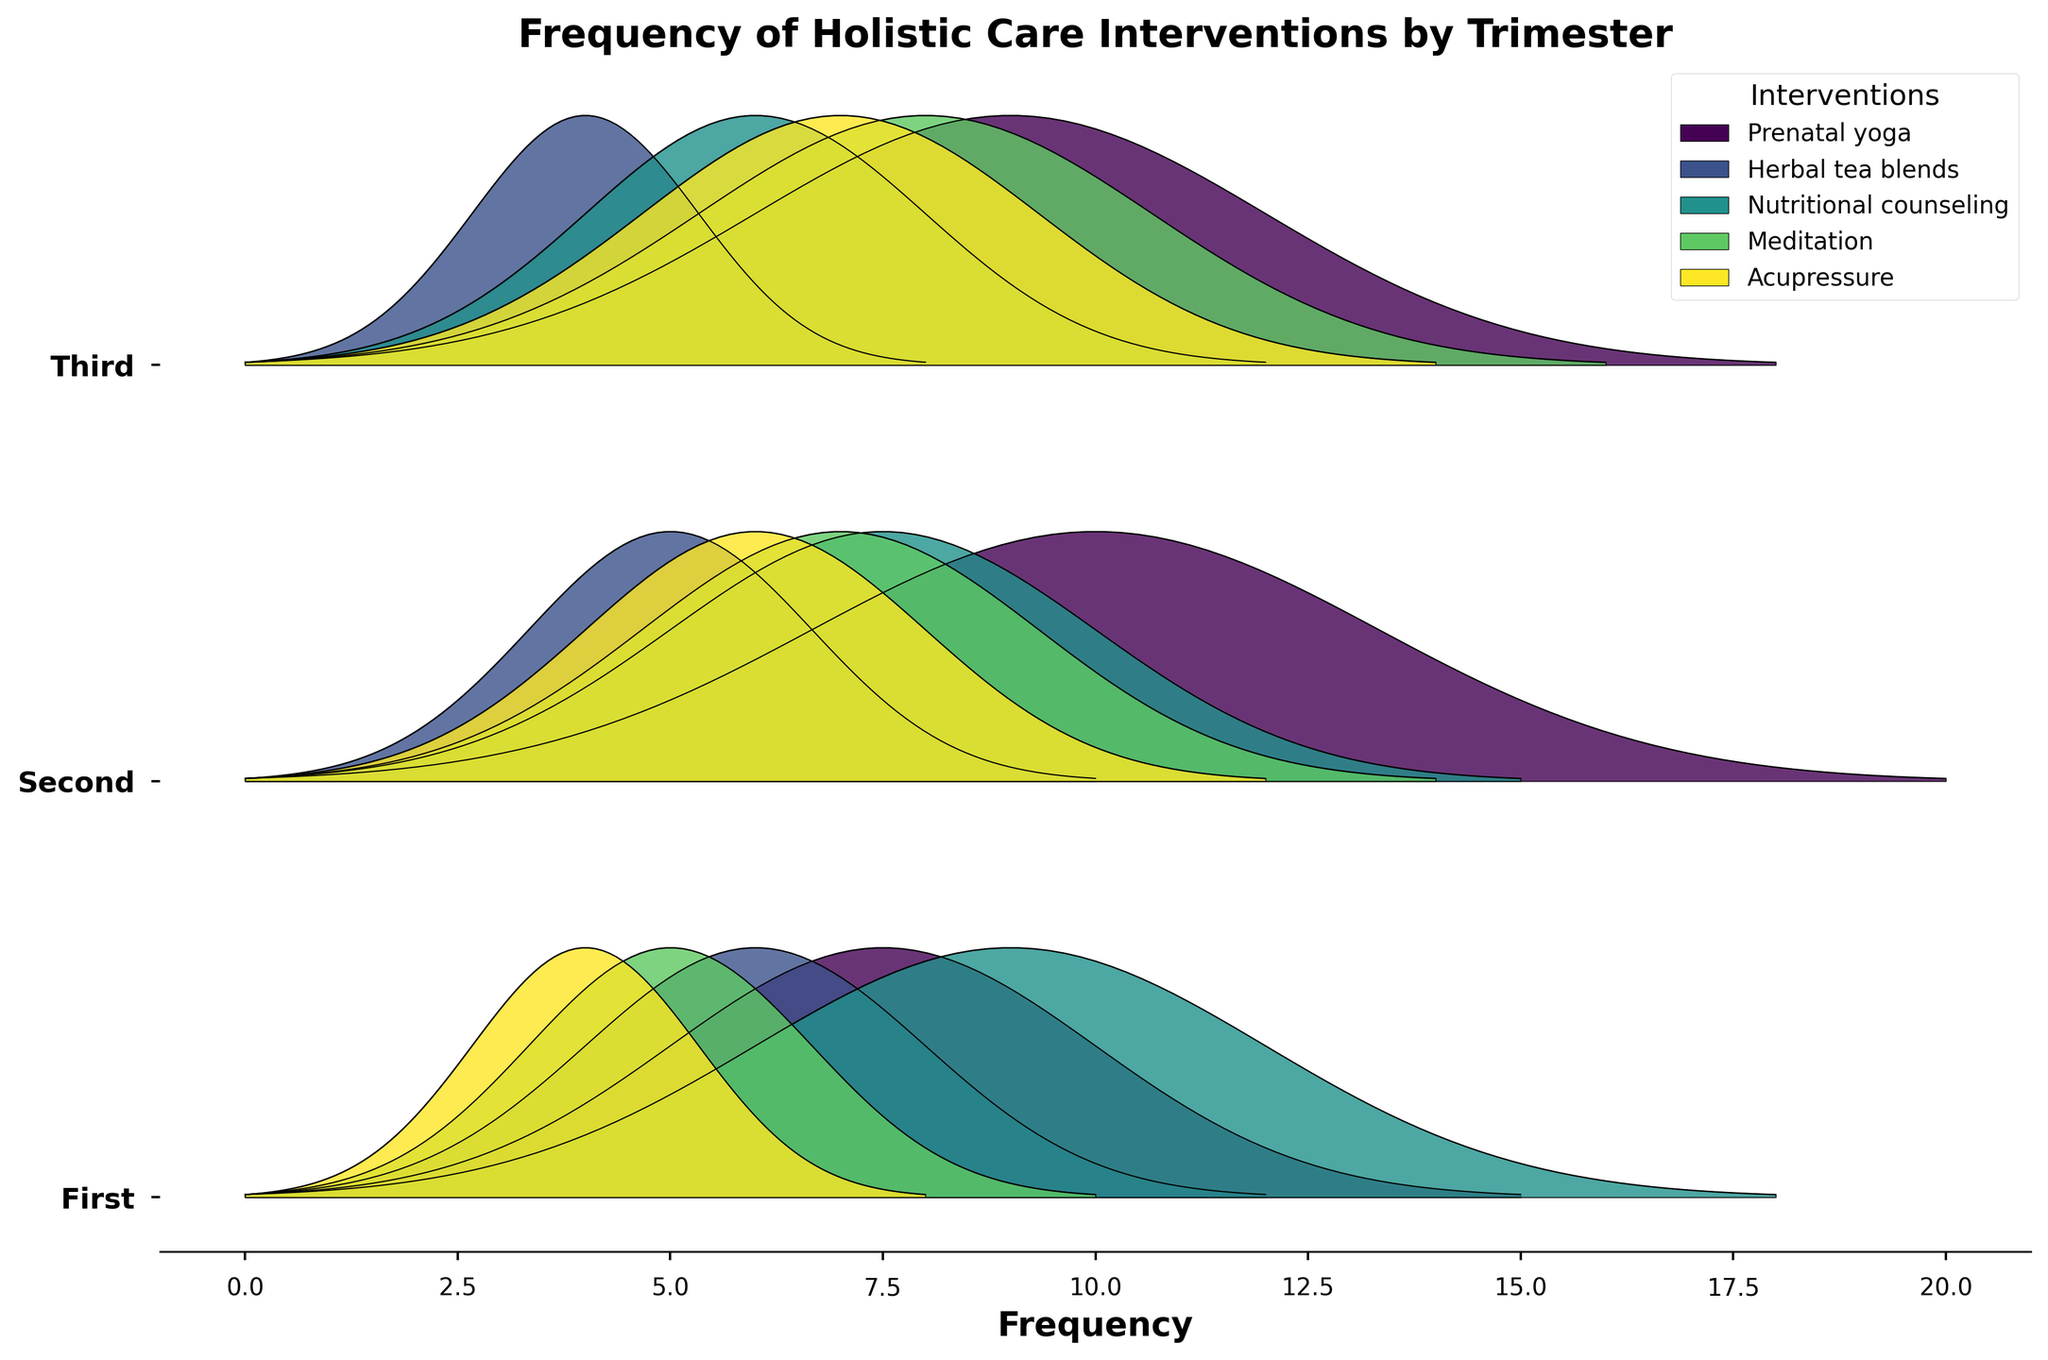Which trimester has the highest frequency for Meditation? The y-axis labels represent the trimesters, and the curves above each label show the frequency of each intervention. The highest point of the Meditation curve is highest for the Third trimester.
Answer: Third Which holistic care intervention shows the most consistent frequency across all trimesters? By analyzing the height of the curves for each intervention across all three trimesters, Nutritional counseling maintains relatively similar heights, reflecting a more consistent frequency.
Answer: Nutritional counseling What is the frequency difference of Acupressure between the First and Third trimesters? The curve for Acupressure in the First trimester peaks at 8, while in the Third trimester, it peaks at 14. The difference is 14 - 8.
Answer: 6 Which trimester has the lowest frequency for Herbal tea blends? The curves for Herbal tea blends across all trimesters show the lowest peak in the Third trimester.
Answer: Third Does the frequency of Prenatal yoga increase or decrease over the trimesters? Observing the peaks of Prenatal yoga's curves, it increases from the First trimester (15) to the Second trimester (20) and then decreases in the Third trimester (18).
Answer: Increases, then decreases How does the frequency of Meditation in the Third trimester compare to that in the First trimester? The Meditation frequency in the First trimester is 10, whereas in the Third trimester it is 16, showing an increase.
Answer: Higher in the Third For which trimester is the frequency of Herbal tea blends closest to the frequency of Acupressure? Looking at the peaks, Herbal tea blends and Acupressure are both at 12 during the Second trimester.
Answer: Second Which intervention has the highest frequency in the Second trimester? The curves for each intervention in the Second trimester show the tallest peak for Prenatal yoga.
Answer: Prenatal yoga 